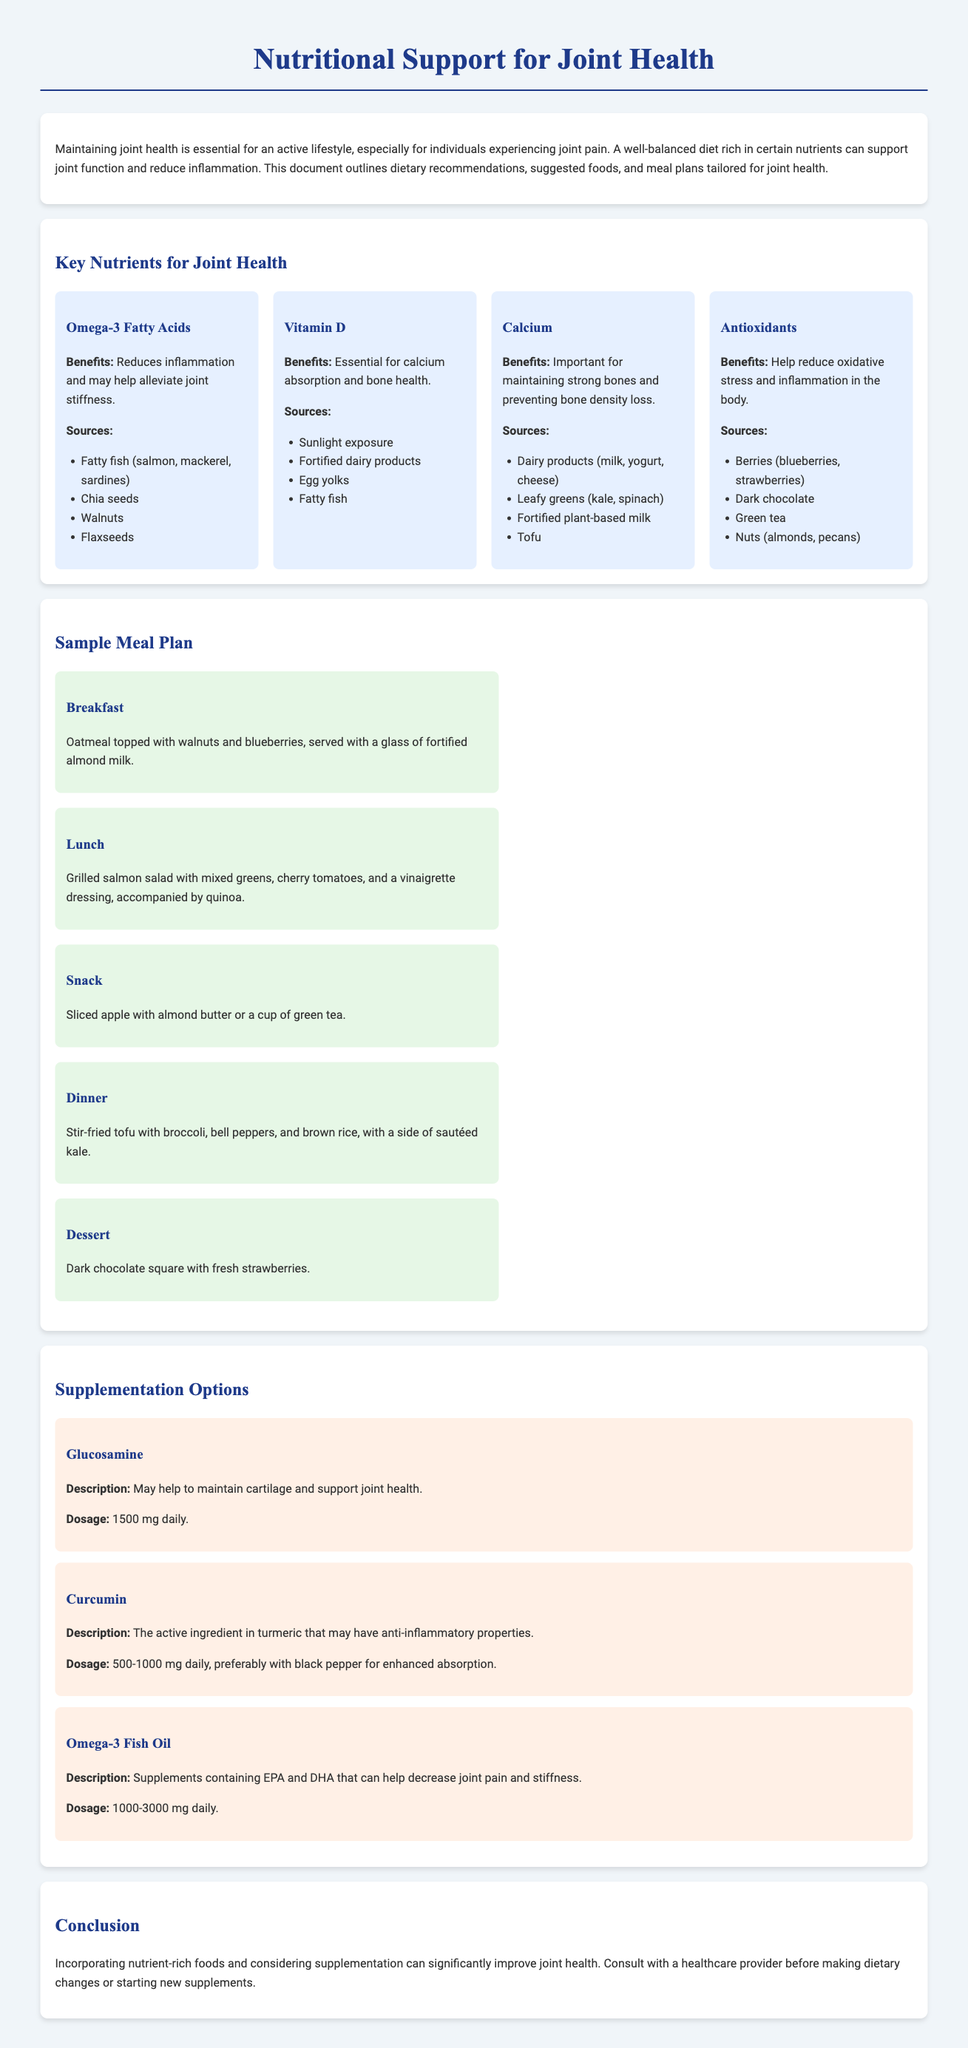What are the key nutrients for joint health? The document lists several key nutrients, including Omega-3 Fatty Acids, Vitamin D, Calcium, and Antioxidants.
Answer: Omega-3 Fatty Acids, Vitamin D, Calcium, Antioxidants What is the benefit of Omega-3 fatty acids? The benefits are outlined in the document, specifically mentioning their role in reducing inflammation and alleviating joint stiffness.
Answer: Reduces inflammation and may help alleviate joint stiffness What is an example of a breakfast from the sample meal plan? The document provides specific examples of meals, indicating oatmeal topped with walnuts and blueberries as a breakfast option.
Answer: Oatmeal topped with walnuts and blueberries What is the recommended dosage for Omega-3 fish oil supplementation? The document specifies the dosage recommendations for Omega-3 Fish Oil.
Answer: 1000-3000 mg daily What food source is rich in Vitamin D? The document lists several food sources for Vitamin D, including fortified dairy products.
Answer: Fortified dairy products What does Curcumin do? The document includes information about Curcumin, stating that it may have anti-inflammatory properties.
Answer: May have anti-inflammatory properties Name one antioxidant-rich food listed in the document. The document mentions several sources of antioxidants, with berries being a key example.
Answer: Berries What type of document is this? The structure and content of the document suggest it serves as an informative guide on dietary recommendations for joint health.
Answer: Informative document 